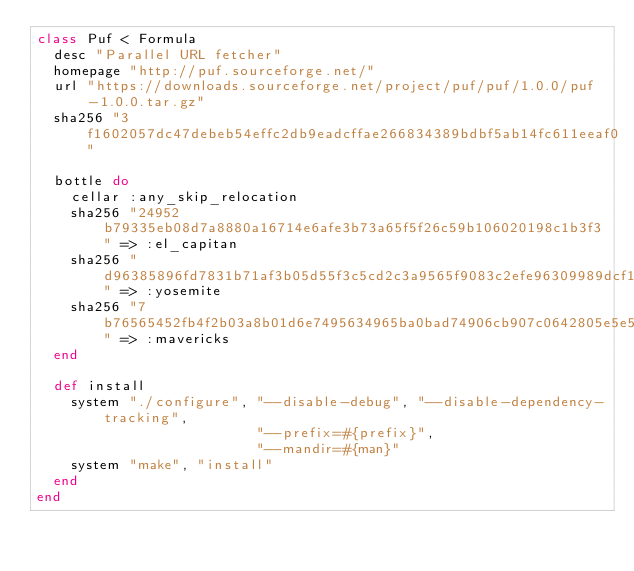Convert code to text. <code><loc_0><loc_0><loc_500><loc_500><_Ruby_>class Puf < Formula
  desc "Parallel URL fetcher"
  homepage "http://puf.sourceforge.net/"
  url "https://downloads.sourceforge.net/project/puf/puf/1.0.0/puf-1.0.0.tar.gz"
  sha256 "3f1602057dc47debeb54effc2db9eadcffae266834389bdbf5ab14fc611eeaf0"

  bottle do
    cellar :any_skip_relocation
    sha256 "24952b79335eb08d7a8880a16714e6afe3b73a65f5f26c59b106020198c1b3f3" => :el_capitan
    sha256 "d96385896fd7831b71af3b05d55f3c5cd2c3a9565f9083c2efe96309989dcf15" => :yosemite
    sha256 "7b76565452fb4f2b03a8b01d6e7495634965ba0bad74906cb907c0642805e5e5" => :mavericks
  end

  def install
    system "./configure", "--disable-debug", "--disable-dependency-tracking",
                          "--prefix=#{prefix}",
                          "--mandir=#{man}"
    system "make", "install"
  end
end
</code> 